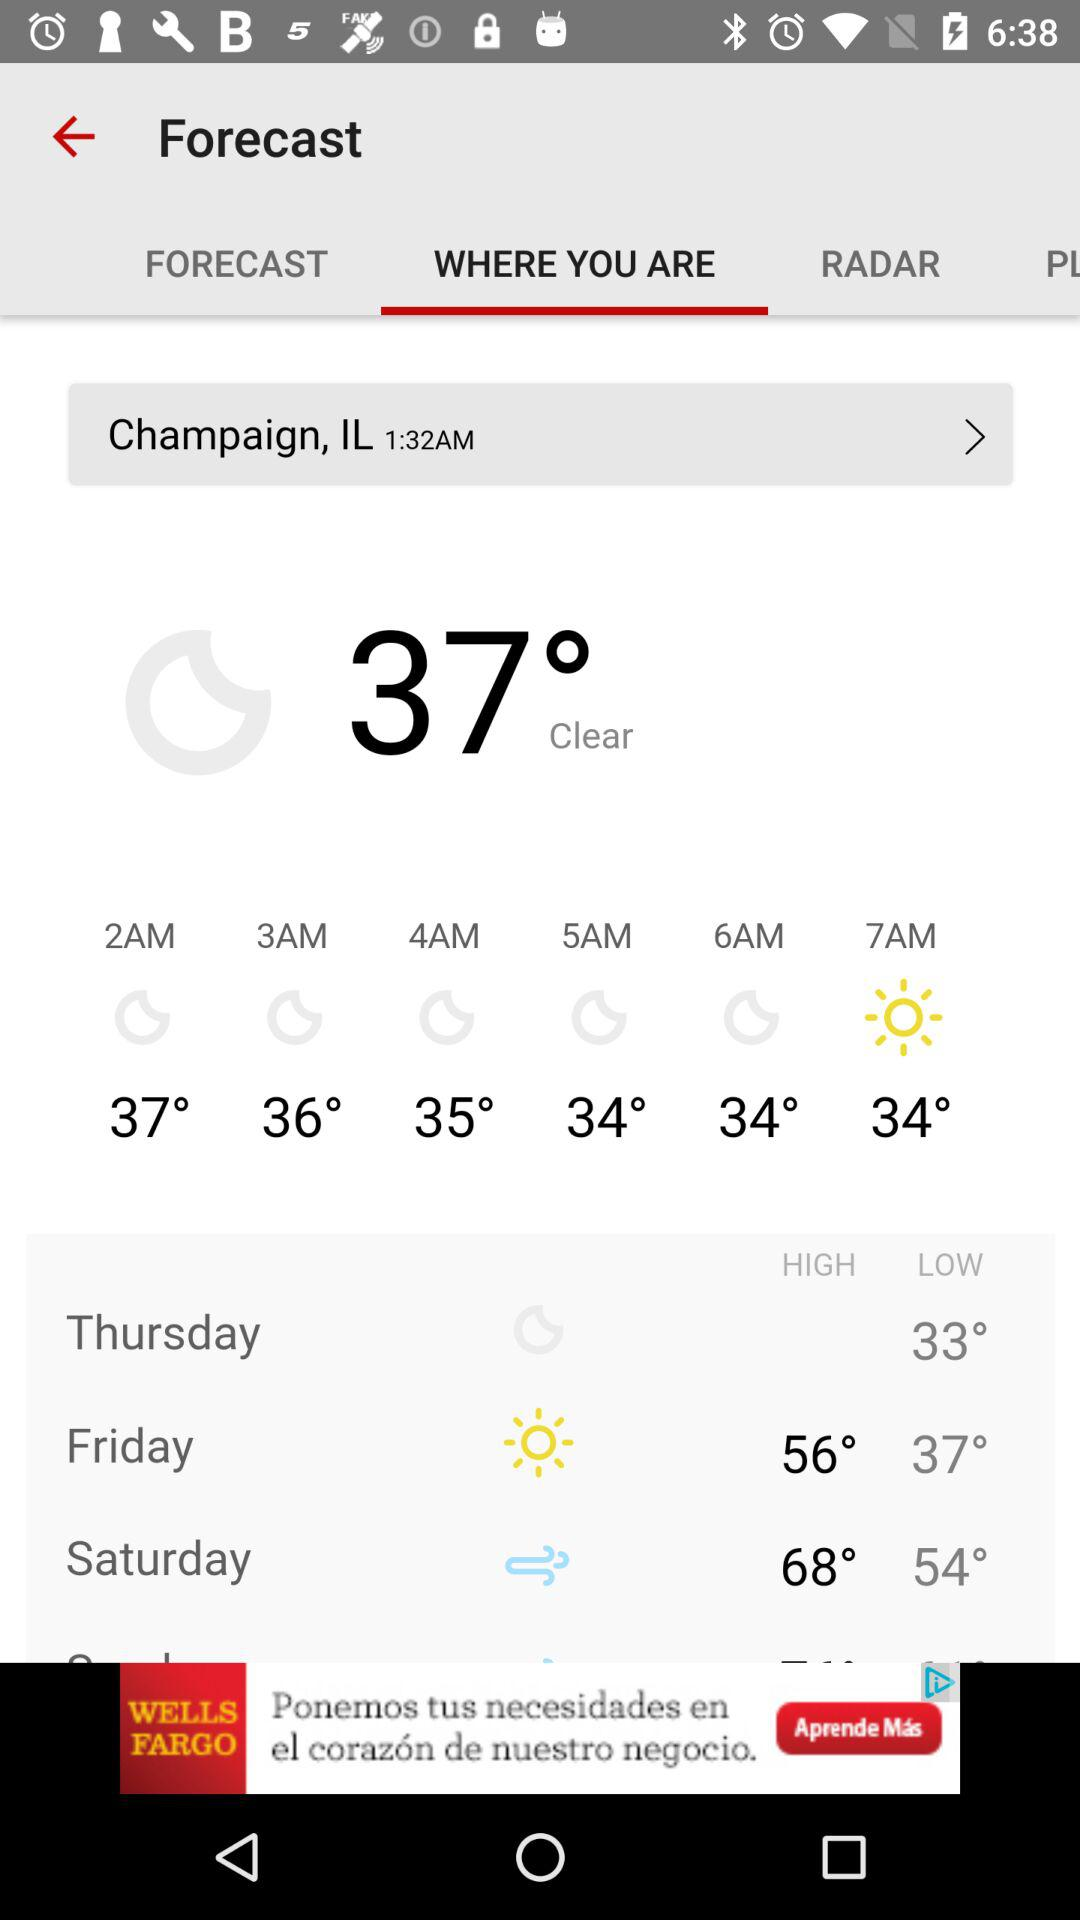What is the temperature? The temperature is 37°. 